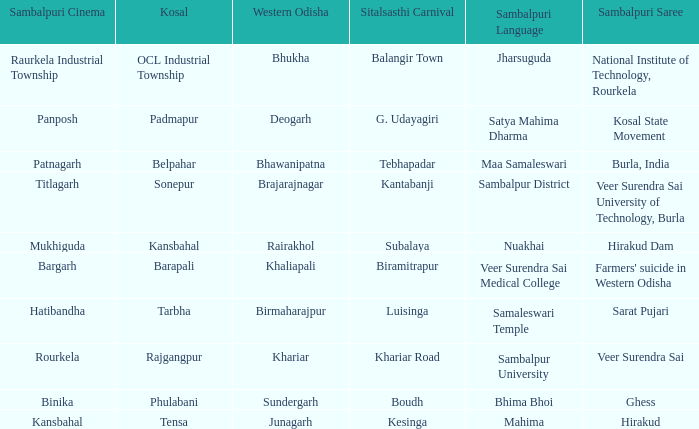What is the kosal with hatibandha as the sambalpuri cinema? Tarbha. Could you parse the entire table? {'header': ['Sambalpuri Cinema', 'Kosal', 'Western Odisha', 'Sitalsasthi Carnival', 'Sambalpuri Language', 'Sambalpuri Saree'], 'rows': [['Raurkela Industrial Township', 'OCL Industrial Township', 'Bhukha', 'Balangir Town', 'Jharsuguda', 'National Institute of Technology, Rourkela'], ['Panposh', 'Padmapur', 'Deogarh', 'G. Udayagiri', 'Satya Mahima Dharma', 'Kosal State Movement'], ['Patnagarh', 'Belpahar', 'Bhawanipatna', 'Tebhapadar', 'Maa Samaleswari', 'Burla, India'], ['Titlagarh', 'Sonepur', 'Brajarajnagar', 'Kantabanji', 'Sambalpur District', 'Veer Surendra Sai University of Technology, Burla'], ['Mukhiguda', 'Kansbahal', 'Rairakhol', 'Subalaya', 'Nuakhai', 'Hirakud Dam'], ['Bargarh', 'Barapali', 'Khaliapali', 'Biramitrapur', 'Veer Surendra Sai Medical College', "Farmers' suicide in Western Odisha"], ['Hatibandha', 'Tarbha', 'Birmaharajpur', 'Luisinga', 'Samaleswari Temple', 'Sarat Pujari'], ['Rourkela', 'Rajgangpur', 'Khariar', 'Khariar Road', 'Sambalpur University', 'Veer Surendra Sai'], ['Binika', 'Phulabani', 'Sundergarh', 'Boudh', 'Bhima Bhoi', 'Ghess'], ['Kansbahal', 'Tensa', 'Junagarh', 'Kesinga', 'Mahima', 'Hirakud']]} 